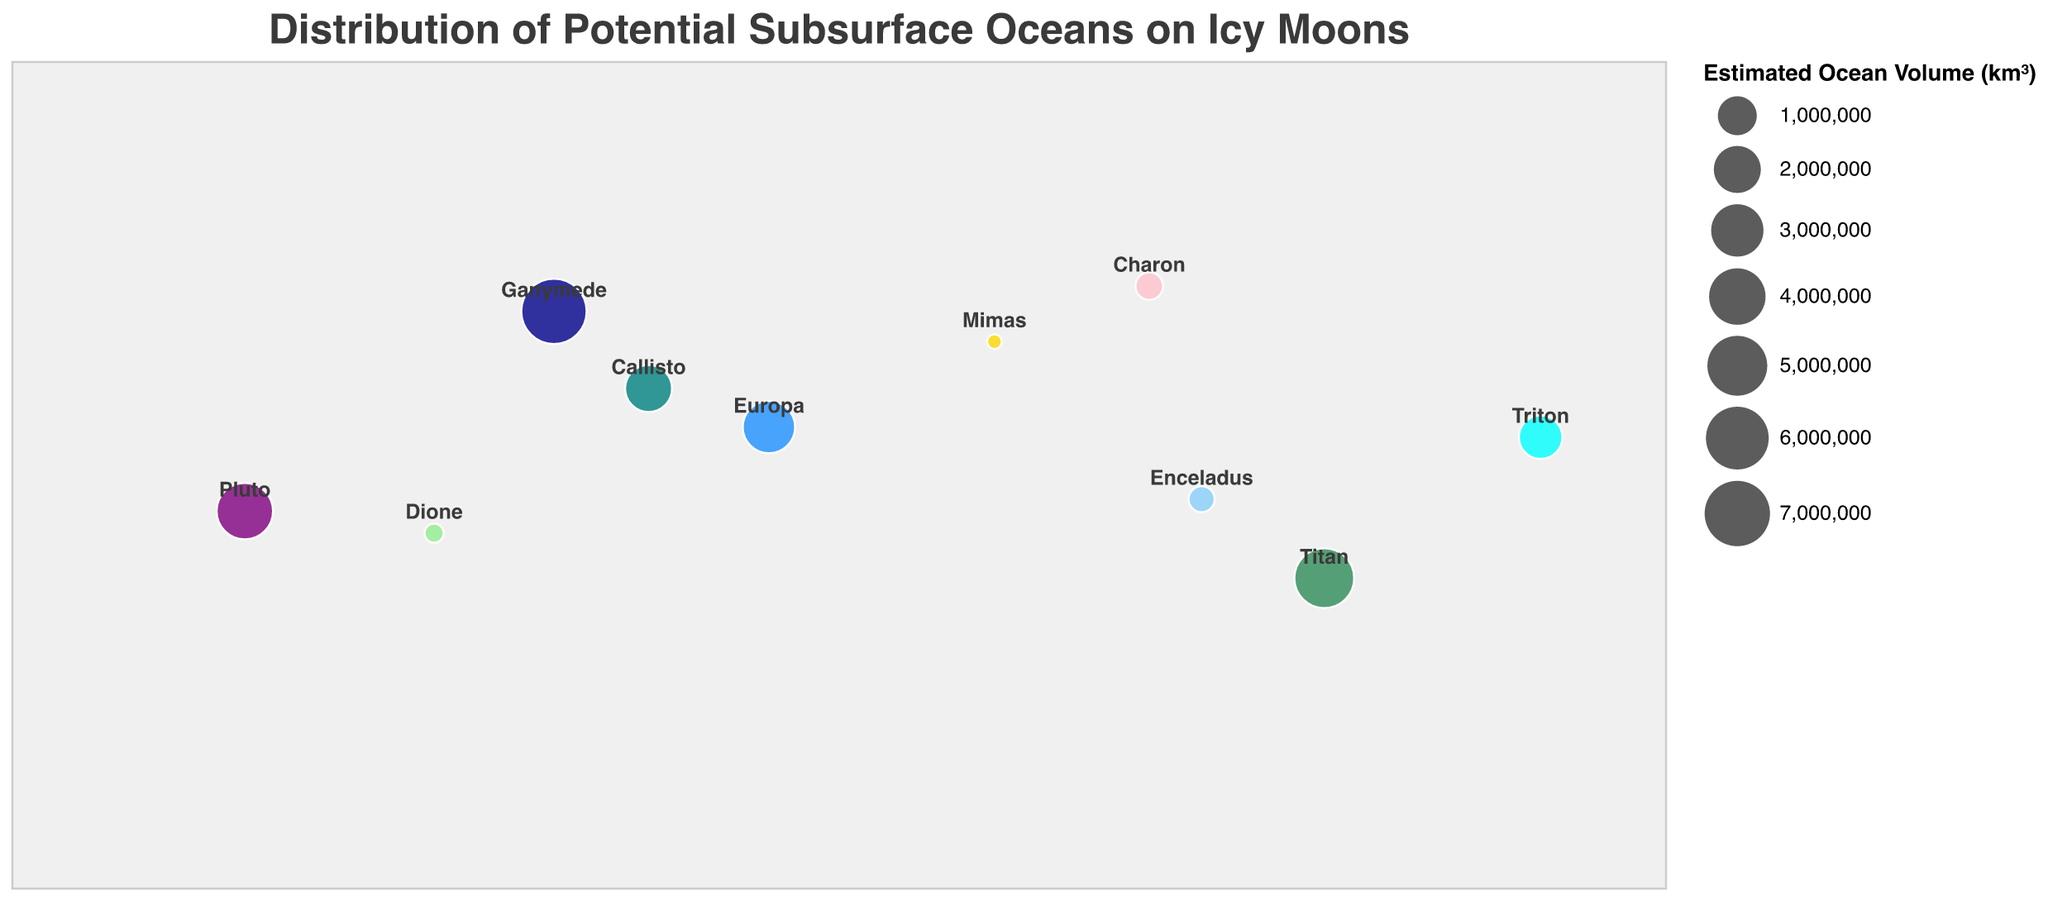What is the title of the figure? The title is written at the top of the figure in bold font. It provides an overview of what the figure is about.
Answer: Distribution of Potential Subsurface Oceans on Icy Moons What does the color code represent in the figure? The color code distinguishes the different moons and possibly gives an idea about their respective ocean volumes. For example, Europa is blue, Enceladus is light blue, etc.
Answer: Different moons Which moon has the largest estimated ocean volume? The size of the circles and the corresponding ocean volume indicated by the legend help identify the moon with the largest volume. Ganymede has the largest circle size, indicating 7,000,000 km³.
Answer: Ganymede How many moons have an estimated ocean volume of over 1,000,000 km³? By reading the circle sizes and referring to the legend, we can count the moons that have an estimated ocean volume above 1,000,000 km³: Europa, Ganymede, Titan, Callisto, and Pluto.
Answer: 5 What are the latitude and longitude coordinates of Europa? The tooltip or text near the data point provides the latitude and longitude coordinates of Europa. Europa's data point shows coordinates at 10.5 (Latitude) and -15.3 (Longitude).
Answer: 10.5, -15.3 Compare the estimated ocean volumes of Enceladus and Dione. Which one is larger and by how much? By looking at the size of the circles, Enceladus has 250,000 km³, and Dione has 100,000 km³. The difference is 250,000 km³ - 100,000 km³ = 150,000 km³.
Answer: Enceladus by 150,000 km³ What is the average estimated ocean volume of moons located in the southern hemisphere (negative latitude)? The southern hemisphere moons are Enceladus, Titan, Dione, and Pluto. Their volumes are 250,000 + 5,000,000 + 100,000 + 4,000,000 = 9,350,000 km³. Average = 9,350,000 / 4 = 2,337,500 km³.
Answer: 2,337,500 km³ Which moon is closest to the equator? The moon with latitude closest to 0 is Enceladus, with a latitude of -5.2.
Answer: Enceladus Are there more moons in the Northern or Southern Hemisphere based on the given data? By counting the moons based on their latitude coordinates, there are 5 moons in the Northern Hemisphere (Europa, Ganymede, Callisto, Mimas, Charon) and 5 in the Southern Hemisphere (Enceladus, Titan, Triton, Dione, Pluto).
Answer: Equal number 